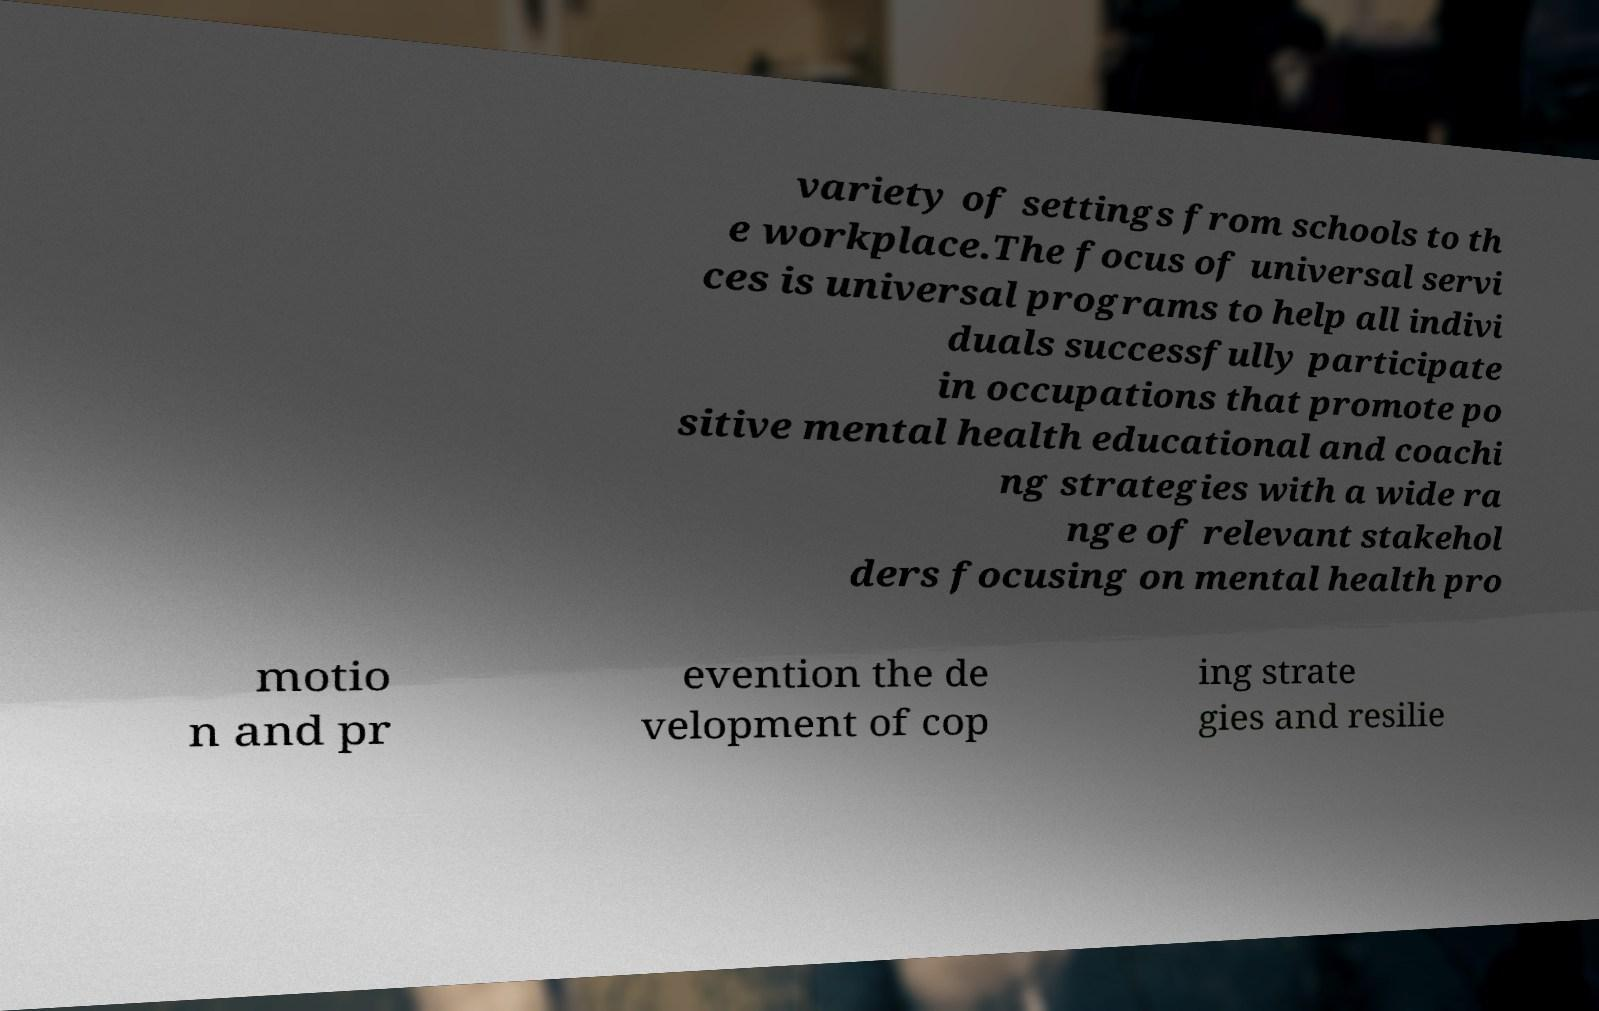Please identify and transcribe the text found in this image. variety of settings from schools to th e workplace.The focus of universal servi ces is universal programs to help all indivi duals successfully participate in occupations that promote po sitive mental health educational and coachi ng strategies with a wide ra nge of relevant stakehol ders focusing on mental health pro motio n and pr evention the de velopment of cop ing strate gies and resilie 